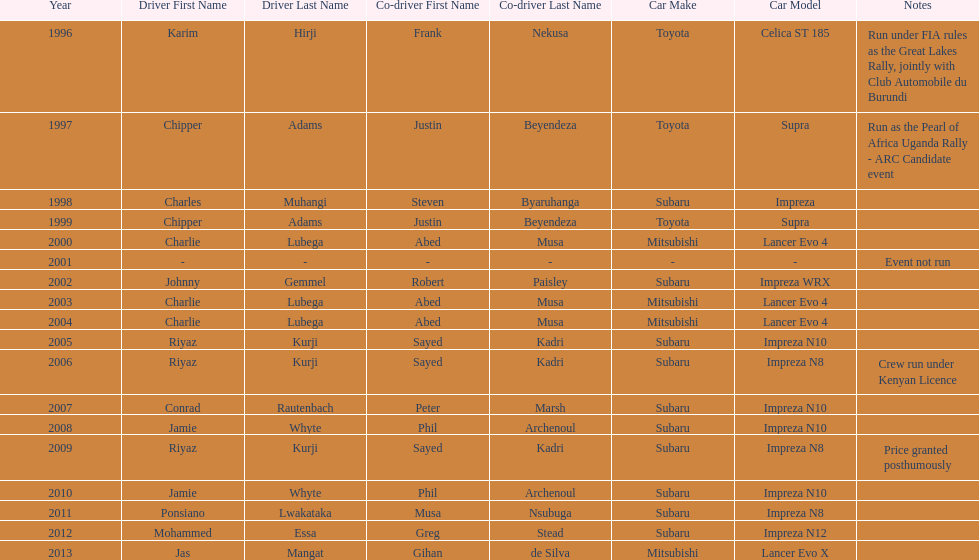What is the total number of times that the winning driver was driving a toyota supra? 2. 